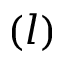Convert formula to latex. <formula><loc_0><loc_0><loc_500><loc_500>( l )</formula> 